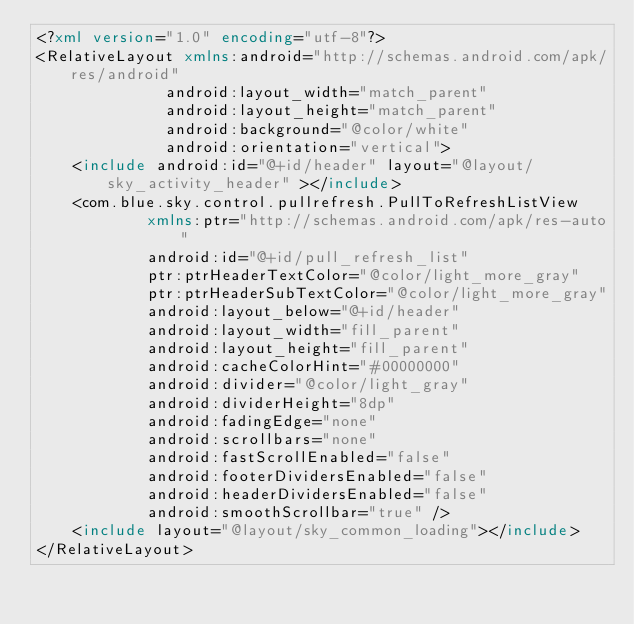Convert code to text. <code><loc_0><loc_0><loc_500><loc_500><_XML_><?xml version="1.0" encoding="utf-8"?>
<RelativeLayout xmlns:android="http://schemas.android.com/apk/res/android"
              android:layout_width="match_parent"
              android:layout_height="match_parent"
              android:background="@color/white"
              android:orientation="vertical">
    <include android:id="@+id/header" layout="@layout/sky_activity_header" ></include>
    <com.blue.sky.control.pullrefresh.PullToRefreshListView
            xmlns:ptr="http://schemas.android.com/apk/res-auto"
            android:id="@+id/pull_refresh_list"
            ptr:ptrHeaderTextColor="@color/light_more_gray"
            ptr:ptrHeaderSubTextColor="@color/light_more_gray"
            android:layout_below="@+id/header"
            android:layout_width="fill_parent"
            android:layout_height="fill_parent"
            android:cacheColorHint="#00000000"
            android:divider="@color/light_gray"
            android:dividerHeight="8dp"
            android:fadingEdge="none"
            android:scrollbars="none"
            android:fastScrollEnabled="false"
            android:footerDividersEnabled="false"
            android:headerDividersEnabled="false"
            android:smoothScrollbar="true" />
    <include layout="@layout/sky_common_loading"></include>
</RelativeLayout>
</code> 